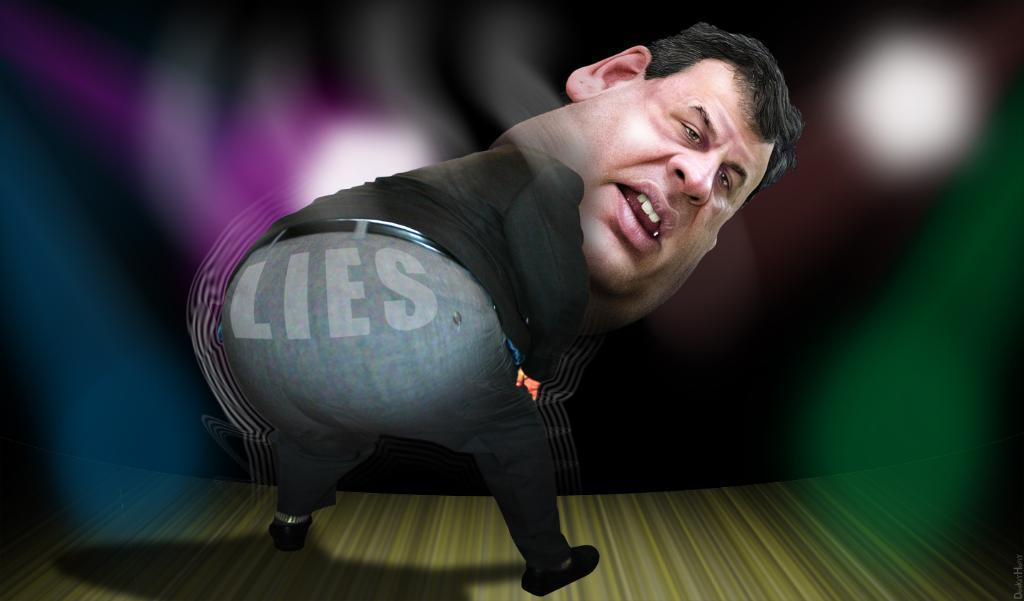What can be observed about the nature of the image? The image is edited. What is the main subject of the image? There is a depiction of a person in the center of the image. What type of milk is being poured by the person in the image? There is no milk present in the image; it only depicts a person in the center. 